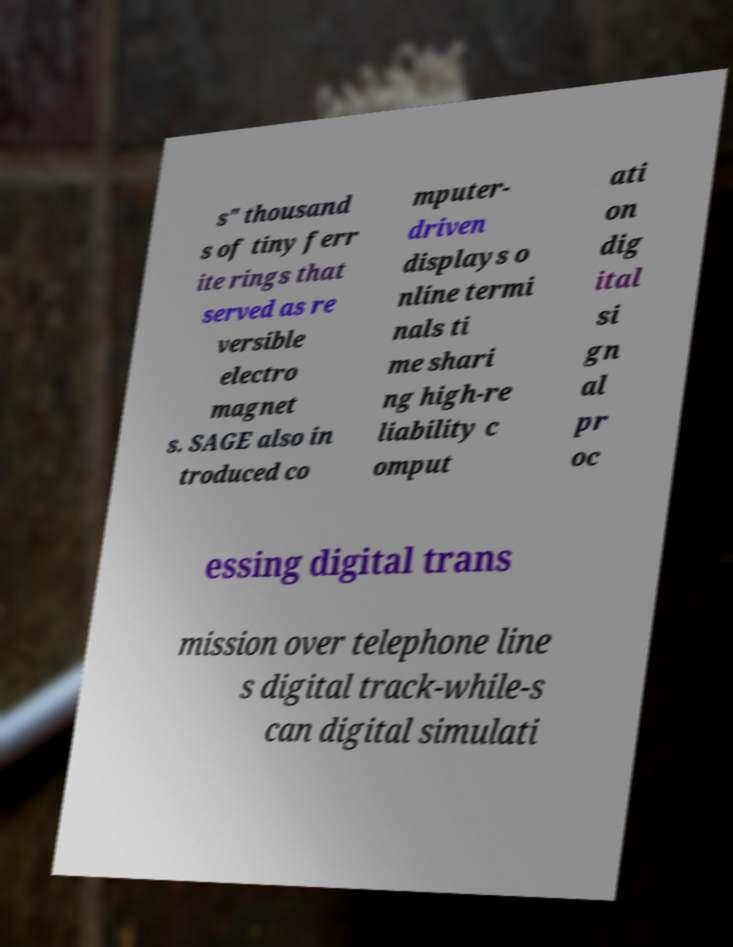Could you assist in decoding the text presented in this image and type it out clearly? s" thousand s of tiny ferr ite rings that served as re versible electro magnet s. SAGE also in troduced co mputer- driven displays o nline termi nals ti me shari ng high-re liability c omput ati on dig ital si gn al pr oc essing digital trans mission over telephone line s digital track-while-s can digital simulati 